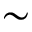Convert formula to latex. <formula><loc_0><loc_0><loc_500><loc_500>\sim</formula> 